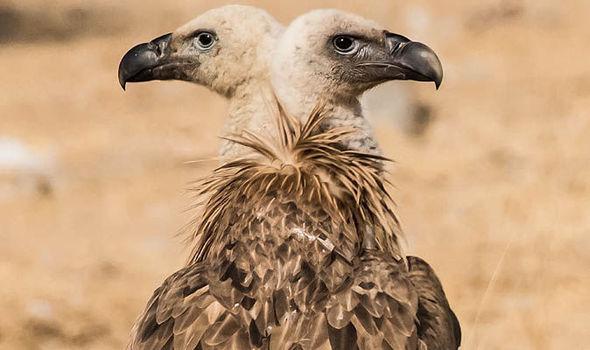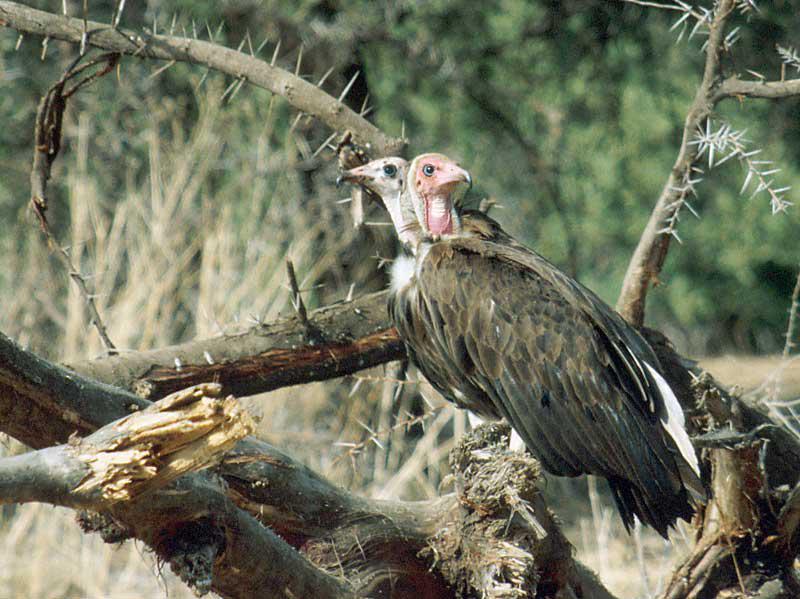The first image is the image on the left, the second image is the image on the right. For the images shown, is this caption "One of the birds appears to have two heads in one of the images." true? Answer yes or no. Yes. The first image is the image on the left, the second image is the image on the right. For the images shown, is this caption "Overlapping vultures face opposite directions in the center of one image, which has a brown background." true? Answer yes or no. Yes. 